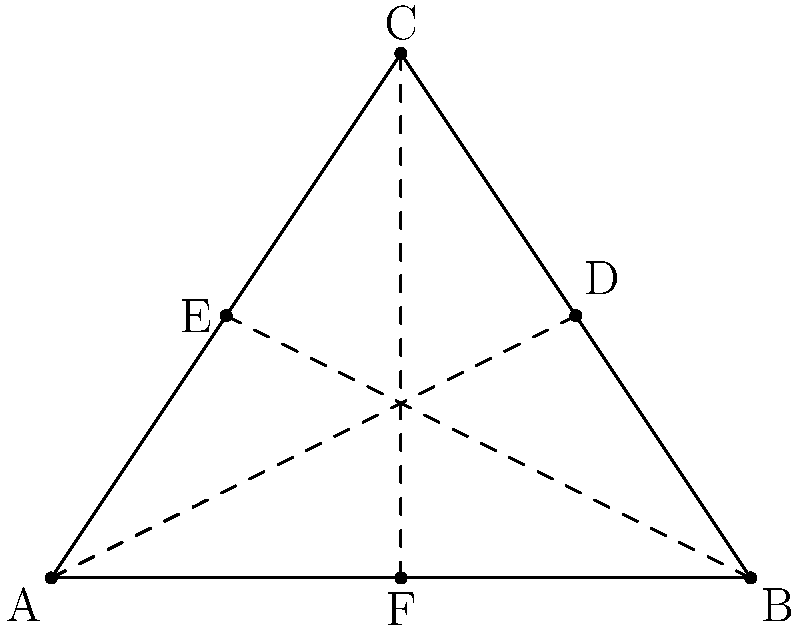In analyzing the geometric patterns of an ancient musical notation system, you discover a triangular arrangement of notes. The midpoints of each side of this triangle are connected to the opposite vertex, as shown in the diagram. What theorem describes the key property of these lines, and how might this relate to harmonic structures in the ancient composition? To answer this question, let's analyze the diagram step-by-step:

1. We have a triangle ABC with midpoints D, E, and F on its sides.
2. Lines AD, BE, and CF are drawn from each vertex to the midpoint of the opposite side.

These lines are called the medians of the triangle. The key property of these medians is described by the Centroid Theorem, which states:

3. The medians of a triangle all intersect at a single point called the centroid.
4. The centroid divides each median in a 2:1 ratio, with the longer segment closer to the vertex.

This geometric property might relate to harmonic structures in ancient music in several ways:

5. The 2:1 ratio is significant in music theory, representing the octave interval.
6. The centroid could represent a central or fundamental tone in the composition.
7. The three medians might represent different harmonic series or scales based on each of the triangle's vertices.
8. The geometric balance of the centroid could symbolize harmonic balance in the musical structure.

In the context of digital archaeology and ancient music reconstruction, this geometric pattern could provide insights into the mathematical basis of the composition, potentially revealing hidden harmonies or structural elements in the music.
Answer: Centroid Theorem; 2:1 ratio symbolizes octave, centroid as fundamental tone 